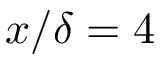<formula> <loc_0><loc_0><loc_500><loc_500>x / \delta = 4</formula> 